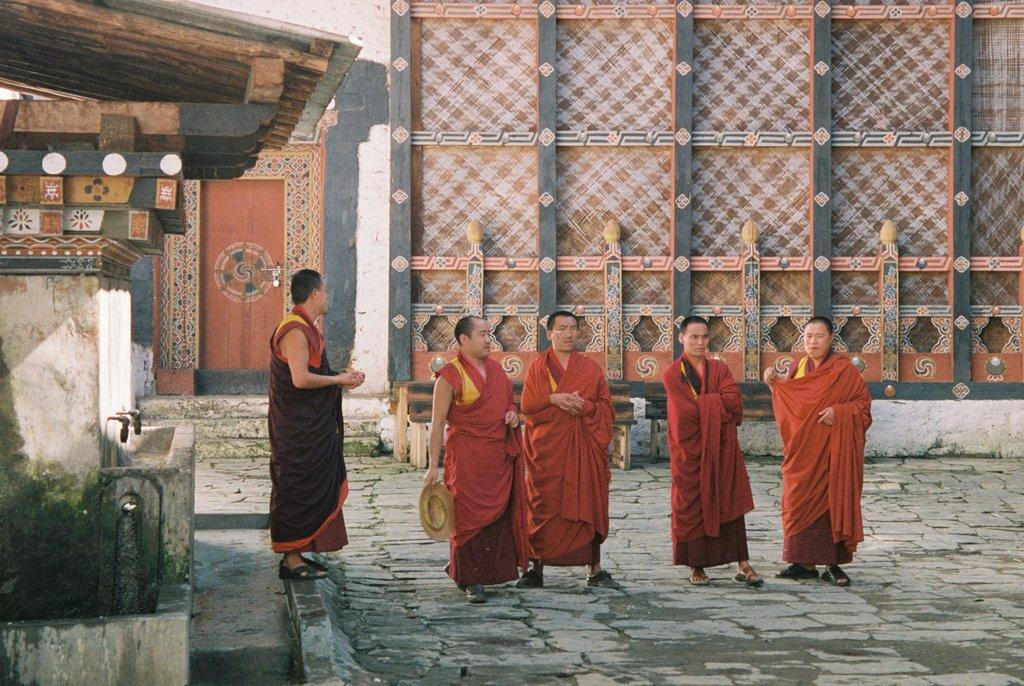What can be observed about the people in the image? There are people standing in the image, and they are wearing red-colored dresses. Can you describe any specific object held by one of the people? Yes, a man is holding a hat in his hand. What is visible in the background of the image? There is a door visible in the background of the image. What type of pancake is being served at the event in the image? There is no event or pancake present in the image; it features people standing and wearing red-colored dresses. How does the man feel about holding the hat in the image? The image does not provide information about the man's feelings or emotions, so we cannot determine how he feels about holding the hat. 